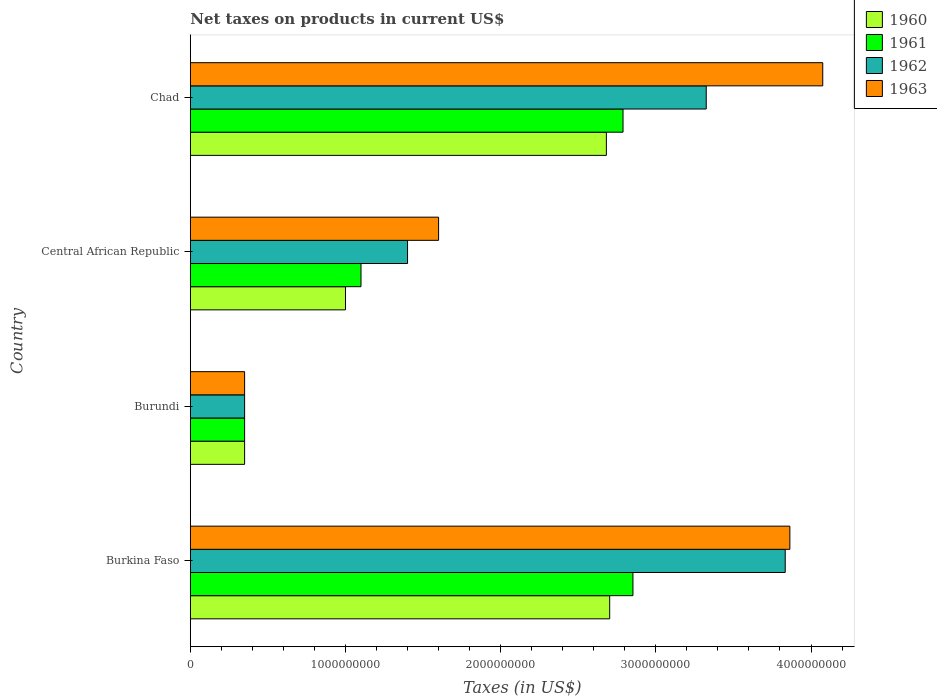Are the number of bars per tick equal to the number of legend labels?
Your answer should be very brief. Yes. How many bars are there on the 1st tick from the bottom?
Make the answer very short. 4. What is the label of the 1st group of bars from the top?
Your response must be concise. Chad. What is the net taxes on products in 1961 in Central African Republic?
Give a very brief answer. 1.10e+09. Across all countries, what is the maximum net taxes on products in 1962?
Offer a terse response. 3.83e+09. Across all countries, what is the minimum net taxes on products in 1961?
Make the answer very short. 3.50e+08. In which country was the net taxes on products in 1960 maximum?
Your response must be concise. Burkina Faso. In which country was the net taxes on products in 1963 minimum?
Give a very brief answer. Burundi. What is the total net taxes on products in 1963 in the graph?
Offer a very short reply. 9.89e+09. What is the difference between the net taxes on products in 1962 in Burundi and that in Chad?
Your response must be concise. -2.97e+09. What is the difference between the net taxes on products in 1962 in Chad and the net taxes on products in 1960 in Central African Republic?
Give a very brief answer. 2.32e+09. What is the average net taxes on products in 1961 per country?
Your answer should be compact. 1.77e+09. What is the difference between the net taxes on products in 1961 and net taxes on products in 1960 in Central African Republic?
Ensure brevity in your answer.  1.00e+08. What is the ratio of the net taxes on products in 1961 in Burkina Faso to that in Central African Republic?
Ensure brevity in your answer.  2.59. Is the difference between the net taxes on products in 1961 in Burundi and Chad greater than the difference between the net taxes on products in 1960 in Burundi and Chad?
Provide a short and direct response. No. What is the difference between the highest and the second highest net taxes on products in 1960?
Keep it short and to the point. 2.13e+07. What is the difference between the highest and the lowest net taxes on products in 1962?
Your answer should be very brief. 3.48e+09. In how many countries, is the net taxes on products in 1962 greater than the average net taxes on products in 1962 taken over all countries?
Give a very brief answer. 2. What does the 3rd bar from the top in Chad represents?
Make the answer very short. 1961. How many bars are there?
Offer a very short reply. 16. Are all the bars in the graph horizontal?
Provide a short and direct response. Yes. Does the graph contain any zero values?
Give a very brief answer. No. Does the graph contain grids?
Provide a succinct answer. No. Where does the legend appear in the graph?
Your answer should be very brief. Top right. How many legend labels are there?
Give a very brief answer. 4. What is the title of the graph?
Provide a short and direct response. Net taxes on products in current US$. Does "1964" appear as one of the legend labels in the graph?
Make the answer very short. No. What is the label or title of the X-axis?
Your answer should be compact. Taxes (in US$). What is the Taxes (in US$) in 1960 in Burkina Faso?
Provide a succinct answer. 2.70e+09. What is the Taxes (in US$) of 1961 in Burkina Faso?
Provide a succinct answer. 2.85e+09. What is the Taxes (in US$) in 1962 in Burkina Faso?
Your answer should be very brief. 3.83e+09. What is the Taxes (in US$) of 1963 in Burkina Faso?
Your answer should be very brief. 3.86e+09. What is the Taxes (in US$) in 1960 in Burundi?
Provide a succinct answer. 3.50e+08. What is the Taxes (in US$) of 1961 in Burundi?
Provide a succinct answer. 3.50e+08. What is the Taxes (in US$) of 1962 in Burundi?
Offer a terse response. 3.50e+08. What is the Taxes (in US$) in 1963 in Burundi?
Your answer should be very brief. 3.50e+08. What is the Taxes (in US$) of 1960 in Central African Republic?
Your answer should be compact. 1.00e+09. What is the Taxes (in US$) in 1961 in Central African Republic?
Ensure brevity in your answer.  1.10e+09. What is the Taxes (in US$) of 1962 in Central African Republic?
Make the answer very short. 1.40e+09. What is the Taxes (in US$) of 1963 in Central African Republic?
Provide a succinct answer. 1.60e+09. What is the Taxes (in US$) of 1960 in Chad?
Give a very brief answer. 2.68e+09. What is the Taxes (in US$) in 1961 in Chad?
Keep it short and to the point. 2.79e+09. What is the Taxes (in US$) in 1962 in Chad?
Ensure brevity in your answer.  3.32e+09. What is the Taxes (in US$) in 1963 in Chad?
Provide a short and direct response. 4.08e+09. Across all countries, what is the maximum Taxes (in US$) of 1960?
Your response must be concise. 2.70e+09. Across all countries, what is the maximum Taxes (in US$) of 1961?
Offer a terse response. 2.85e+09. Across all countries, what is the maximum Taxes (in US$) of 1962?
Your answer should be compact. 3.83e+09. Across all countries, what is the maximum Taxes (in US$) in 1963?
Your response must be concise. 4.08e+09. Across all countries, what is the minimum Taxes (in US$) in 1960?
Give a very brief answer. 3.50e+08. Across all countries, what is the minimum Taxes (in US$) in 1961?
Ensure brevity in your answer.  3.50e+08. Across all countries, what is the minimum Taxes (in US$) in 1962?
Ensure brevity in your answer.  3.50e+08. Across all countries, what is the minimum Taxes (in US$) in 1963?
Offer a very short reply. 3.50e+08. What is the total Taxes (in US$) in 1960 in the graph?
Your answer should be compact. 6.73e+09. What is the total Taxes (in US$) of 1961 in the graph?
Ensure brevity in your answer.  7.09e+09. What is the total Taxes (in US$) in 1962 in the graph?
Give a very brief answer. 8.91e+09. What is the total Taxes (in US$) in 1963 in the graph?
Offer a very short reply. 9.89e+09. What is the difference between the Taxes (in US$) of 1960 in Burkina Faso and that in Burundi?
Keep it short and to the point. 2.35e+09. What is the difference between the Taxes (in US$) of 1961 in Burkina Faso and that in Burundi?
Provide a succinct answer. 2.50e+09. What is the difference between the Taxes (in US$) in 1962 in Burkina Faso and that in Burundi?
Offer a very short reply. 3.48e+09. What is the difference between the Taxes (in US$) of 1963 in Burkina Faso and that in Burundi?
Provide a short and direct response. 3.51e+09. What is the difference between the Taxes (in US$) in 1960 in Burkina Faso and that in Central African Republic?
Offer a terse response. 1.70e+09. What is the difference between the Taxes (in US$) in 1961 in Burkina Faso and that in Central African Republic?
Your answer should be very brief. 1.75e+09. What is the difference between the Taxes (in US$) of 1962 in Burkina Faso and that in Central African Republic?
Give a very brief answer. 2.43e+09. What is the difference between the Taxes (in US$) in 1963 in Burkina Faso and that in Central African Republic?
Keep it short and to the point. 2.26e+09. What is the difference between the Taxes (in US$) in 1960 in Burkina Faso and that in Chad?
Your answer should be very brief. 2.13e+07. What is the difference between the Taxes (in US$) in 1961 in Burkina Faso and that in Chad?
Ensure brevity in your answer.  6.39e+07. What is the difference between the Taxes (in US$) of 1962 in Burkina Faso and that in Chad?
Offer a terse response. 5.09e+08. What is the difference between the Taxes (in US$) of 1963 in Burkina Faso and that in Chad?
Provide a short and direct response. -2.12e+08. What is the difference between the Taxes (in US$) in 1960 in Burundi and that in Central African Republic?
Your answer should be compact. -6.50e+08. What is the difference between the Taxes (in US$) of 1961 in Burundi and that in Central African Republic?
Keep it short and to the point. -7.50e+08. What is the difference between the Taxes (in US$) of 1962 in Burundi and that in Central African Republic?
Offer a very short reply. -1.05e+09. What is the difference between the Taxes (in US$) of 1963 in Burundi and that in Central African Republic?
Your answer should be very brief. -1.25e+09. What is the difference between the Taxes (in US$) of 1960 in Burundi and that in Chad?
Offer a very short reply. -2.33e+09. What is the difference between the Taxes (in US$) in 1961 in Burundi and that in Chad?
Provide a short and direct response. -2.44e+09. What is the difference between the Taxes (in US$) of 1962 in Burundi and that in Chad?
Offer a very short reply. -2.97e+09. What is the difference between the Taxes (in US$) of 1963 in Burundi and that in Chad?
Make the answer very short. -3.73e+09. What is the difference between the Taxes (in US$) in 1960 in Central African Republic and that in Chad?
Ensure brevity in your answer.  -1.68e+09. What is the difference between the Taxes (in US$) in 1961 in Central African Republic and that in Chad?
Your response must be concise. -1.69e+09. What is the difference between the Taxes (in US$) in 1962 in Central African Republic and that in Chad?
Make the answer very short. -1.92e+09. What is the difference between the Taxes (in US$) of 1963 in Central African Republic and that in Chad?
Your response must be concise. -2.48e+09. What is the difference between the Taxes (in US$) in 1960 in Burkina Faso and the Taxes (in US$) in 1961 in Burundi?
Make the answer very short. 2.35e+09. What is the difference between the Taxes (in US$) of 1960 in Burkina Faso and the Taxes (in US$) of 1962 in Burundi?
Give a very brief answer. 2.35e+09. What is the difference between the Taxes (in US$) in 1960 in Burkina Faso and the Taxes (in US$) in 1963 in Burundi?
Offer a very short reply. 2.35e+09. What is the difference between the Taxes (in US$) of 1961 in Burkina Faso and the Taxes (in US$) of 1962 in Burundi?
Keep it short and to the point. 2.50e+09. What is the difference between the Taxes (in US$) in 1961 in Burkina Faso and the Taxes (in US$) in 1963 in Burundi?
Give a very brief answer. 2.50e+09. What is the difference between the Taxes (in US$) in 1962 in Burkina Faso and the Taxes (in US$) in 1963 in Burundi?
Your answer should be very brief. 3.48e+09. What is the difference between the Taxes (in US$) of 1960 in Burkina Faso and the Taxes (in US$) of 1961 in Central African Republic?
Your answer should be very brief. 1.60e+09. What is the difference between the Taxes (in US$) in 1960 in Burkina Faso and the Taxes (in US$) in 1962 in Central African Republic?
Ensure brevity in your answer.  1.30e+09. What is the difference between the Taxes (in US$) in 1960 in Burkina Faso and the Taxes (in US$) in 1963 in Central African Republic?
Your response must be concise. 1.10e+09. What is the difference between the Taxes (in US$) of 1961 in Burkina Faso and the Taxes (in US$) of 1962 in Central African Republic?
Offer a terse response. 1.45e+09. What is the difference between the Taxes (in US$) of 1961 in Burkina Faso and the Taxes (in US$) of 1963 in Central African Republic?
Ensure brevity in your answer.  1.25e+09. What is the difference between the Taxes (in US$) in 1962 in Burkina Faso and the Taxes (in US$) in 1963 in Central African Republic?
Provide a short and direct response. 2.23e+09. What is the difference between the Taxes (in US$) of 1960 in Burkina Faso and the Taxes (in US$) of 1961 in Chad?
Your answer should be compact. -8.59e+07. What is the difference between the Taxes (in US$) of 1960 in Burkina Faso and the Taxes (in US$) of 1962 in Chad?
Offer a very short reply. -6.22e+08. What is the difference between the Taxes (in US$) of 1960 in Burkina Faso and the Taxes (in US$) of 1963 in Chad?
Give a very brief answer. -1.37e+09. What is the difference between the Taxes (in US$) in 1961 in Burkina Faso and the Taxes (in US$) in 1962 in Chad?
Keep it short and to the point. -4.72e+08. What is the difference between the Taxes (in US$) of 1961 in Burkina Faso and the Taxes (in US$) of 1963 in Chad?
Provide a short and direct response. -1.22e+09. What is the difference between the Taxes (in US$) of 1962 in Burkina Faso and the Taxes (in US$) of 1963 in Chad?
Your response must be concise. -2.42e+08. What is the difference between the Taxes (in US$) in 1960 in Burundi and the Taxes (in US$) in 1961 in Central African Republic?
Ensure brevity in your answer.  -7.50e+08. What is the difference between the Taxes (in US$) of 1960 in Burundi and the Taxes (in US$) of 1962 in Central African Republic?
Give a very brief answer. -1.05e+09. What is the difference between the Taxes (in US$) in 1960 in Burundi and the Taxes (in US$) in 1963 in Central African Republic?
Your response must be concise. -1.25e+09. What is the difference between the Taxes (in US$) of 1961 in Burundi and the Taxes (in US$) of 1962 in Central African Republic?
Keep it short and to the point. -1.05e+09. What is the difference between the Taxes (in US$) in 1961 in Burundi and the Taxes (in US$) in 1963 in Central African Republic?
Provide a succinct answer. -1.25e+09. What is the difference between the Taxes (in US$) in 1962 in Burundi and the Taxes (in US$) in 1963 in Central African Republic?
Offer a terse response. -1.25e+09. What is the difference between the Taxes (in US$) of 1960 in Burundi and the Taxes (in US$) of 1961 in Chad?
Provide a short and direct response. -2.44e+09. What is the difference between the Taxes (in US$) in 1960 in Burundi and the Taxes (in US$) in 1962 in Chad?
Keep it short and to the point. -2.97e+09. What is the difference between the Taxes (in US$) in 1960 in Burundi and the Taxes (in US$) in 1963 in Chad?
Keep it short and to the point. -3.73e+09. What is the difference between the Taxes (in US$) of 1961 in Burundi and the Taxes (in US$) of 1962 in Chad?
Your answer should be compact. -2.97e+09. What is the difference between the Taxes (in US$) in 1961 in Burundi and the Taxes (in US$) in 1963 in Chad?
Make the answer very short. -3.73e+09. What is the difference between the Taxes (in US$) in 1962 in Burundi and the Taxes (in US$) in 1963 in Chad?
Your response must be concise. -3.73e+09. What is the difference between the Taxes (in US$) of 1960 in Central African Republic and the Taxes (in US$) of 1961 in Chad?
Provide a short and direct response. -1.79e+09. What is the difference between the Taxes (in US$) of 1960 in Central African Republic and the Taxes (in US$) of 1962 in Chad?
Your answer should be very brief. -2.32e+09. What is the difference between the Taxes (in US$) in 1960 in Central African Republic and the Taxes (in US$) in 1963 in Chad?
Make the answer very short. -3.08e+09. What is the difference between the Taxes (in US$) of 1961 in Central African Republic and the Taxes (in US$) of 1962 in Chad?
Provide a succinct answer. -2.22e+09. What is the difference between the Taxes (in US$) of 1961 in Central African Republic and the Taxes (in US$) of 1963 in Chad?
Keep it short and to the point. -2.98e+09. What is the difference between the Taxes (in US$) of 1962 in Central African Republic and the Taxes (in US$) of 1963 in Chad?
Provide a succinct answer. -2.68e+09. What is the average Taxes (in US$) in 1960 per country?
Keep it short and to the point. 1.68e+09. What is the average Taxes (in US$) of 1961 per country?
Your response must be concise. 1.77e+09. What is the average Taxes (in US$) in 1962 per country?
Keep it short and to the point. 2.23e+09. What is the average Taxes (in US$) in 1963 per country?
Provide a succinct answer. 2.47e+09. What is the difference between the Taxes (in US$) of 1960 and Taxes (in US$) of 1961 in Burkina Faso?
Your answer should be very brief. -1.50e+08. What is the difference between the Taxes (in US$) of 1960 and Taxes (in US$) of 1962 in Burkina Faso?
Offer a terse response. -1.13e+09. What is the difference between the Taxes (in US$) in 1960 and Taxes (in US$) in 1963 in Burkina Faso?
Offer a terse response. -1.16e+09. What is the difference between the Taxes (in US$) in 1961 and Taxes (in US$) in 1962 in Burkina Faso?
Provide a succinct answer. -9.81e+08. What is the difference between the Taxes (in US$) in 1961 and Taxes (in US$) in 1963 in Burkina Faso?
Provide a short and direct response. -1.01e+09. What is the difference between the Taxes (in US$) in 1962 and Taxes (in US$) in 1963 in Burkina Faso?
Provide a succinct answer. -3.00e+07. What is the difference between the Taxes (in US$) in 1960 and Taxes (in US$) in 1963 in Burundi?
Your response must be concise. 0. What is the difference between the Taxes (in US$) in 1962 and Taxes (in US$) in 1963 in Burundi?
Provide a short and direct response. 0. What is the difference between the Taxes (in US$) of 1960 and Taxes (in US$) of 1961 in Central African Republic?
Provide a short and direct response. -1.00e+08. What is the difference between the Taxes (in US$) in 1960 and Taxes (in US$) in 1962 in Central African Republic?
Offer a very short reply. -4.00e+08. What is the difference between the Taxes (in US$) of 1960 and Taxes (in US$) of 1963 in Central African Republic?
Your answer should be compact. -6.00e+08. What is the difference between the Taxes (in US$) of 1961 and Taxes (in US$) of 1962 in Central African Republic?
Make the answer very short. -3.00e+08. What is the difference between the Taxes (in US$) in 1961 and Taxes (in US$) in 1963 in Central African Republic?
Offer a very short reply. -5.00e+08. What is the difference between the Taxes (in US$) in 1962 and Taxes (in US$) in 1963 in Central African Republic?
Provide a short and direct response. -2.00e+08. What is the difference between the Taxes (in US$) of 1960 and Taxes (in US$) of 1961 in Chad?
Your answer should be compact. -1.07e+08. What is the difference between the Taxes (in US$) of 1960 and Taxes (in US$) of 1962 in Chad?
Your response must be concise. -6.44e+08. What is the difference between the Taxes (in US$) in 1960 and Taxes (in US$) in 1963 in Chad?
Your answer should be compact. -1.39e+09. What is the difference between the Taxes (in US$) of 1961 and Taxes (in US$) of 1962 in Chad?
Offer a terse response. -5.36e+08. What is the difference between the Taxes (in US$) in 1961 and Taxes (in US$) in 1963 in Chad?
Your response must be concise. -1.29e+09. What is the difference between the Taxes (in US$) of 1962 and Taxes (in US$) of 1963 in Chad?
Offer a very short reply. -7.51e+08. What is the ratio of the Taxes (in US$) in 1960 in Burkina Faso to that in Burundi?
Offer a very short reply. 7.72. What is the ratio of the Taxes (in US$) in 1961 in Burkina Faso to that in Burundi?
Your answer should be compact. 8.15. What is the ratio of the Taxes (in US$) in 1962 in Burkina Faso to that in Burundi?
Your answer should be compact. 10.95. What is the ratio of the Taxes (in US$) of 1963 in Burkina Faso to that in Burundi?
Your answer should be very brief. 11.04. What is the ratio of the Taxes (in US$) in 1960 in Burkina Faso to that in Central African Republic?
Make the answer very short. 2.7. What is the ratio of the Taxes (in US$) in 1961 in Burkina Faso to that in Central African Republic?
Provide a succinct answer. 2.59. What is the ratio of the Taxes (in US$) in 1962 in Burkina Faso to that in Central African Republic?
Your answer should be compact. 2.74. What is the ratio of the Taxes (in US$) of 1963 in Burkina Faso to that in Central African Republic?
Offer a terse response. 2.41. What is the ratio of the Taxes (in US$) of 1961 in Burkina Faso to that in Chad?
Offer a terse response. 1.02. What is the ratio of the Taxes (in US$) of 1962 in Burkina Faso to that in Chad?
Provide a short and direct response. 1.15. What is the ratio of the Taxes (in US$) in 1963 in Burkina Faso to that in Chad?
Your response must be concise. 0.95. What is the ratio of the Taxes (in US$) in 1961 in Burundi to that in Central African Republic?
Offer a terse response. 0.32. What is the ratio of the Taxes (in US$) in 1962 in Burundi to that in Central African Republic?
Offer a very short reply. 0.25. What is the ratio of the Taxes (in US$) of 1963 in Burundi to that in Central African Republic?
Your answer should be very brief. 0.22. What is the ratio of the Taxes (in US$) in 1960 in Burundi to that in Chad?
Give a very brief answer. 0.13. What is the ratio of the Taxes (in US$) of 1961 in Burundi to that in Chad?
Offer a terse response. 0.13. What is the ratio of the Taxes (in US$) of 1962 in Burundi to that in Chad?
Make the answer very short. 0.11. What is the ratio of the Taxes (in US$) of 1963 in Burundi to that in Chad?
Your response must be concise. 0.09. What is the ratio of the Taxes (in US$) in 1960 in Central African Republic to that in Chad?
Your answer should be compact. 0.37. What is the ratio of the Taxes (in US$) in 1961 in Central African Republic to that in Chad?
Provide a short and direct response. 0.39. What is the ratio of the Taxes (in US$) of 1962 in Central African Republic to that in Chad?
Ensure brevity in your answer.  0.42. What is the ratio of the Taxes (in US$) of 1963 in Central African Republic to that in Chad?
Offer a terse response. 0.39. What is the difference between the highest and the second highest Taxes (in US$) in 1960?
Provide a short and direct response. 2.13e+07. What is the difference between the highest and the second highest Taxes (in US$) in 1961?
Provide a short and direct response. 6.39e+07. What is the difference between the highest and the second highest Taxes (in US$) of 1962?
Provide a short and direct response. 5.09e+08. What is the difference between the highest and the second highest Taxes (in US$) in 1963?
Your answer should be very brief. 2.12e+08. What is the difference between the highest and the lowest Taxes (in US$) in 1960?
Give a very brief answer. 2.35e+09. What is the difference between the highest and the lowest Taxes (in US$) in 1961?
Ensure brevity in your answer.  2.50e+09. What is the difference between the highest and the lowest Taxes (in US$) of 1962?
Give a very brief answer. 3.48e+09. What is the difference between the highest and the lowest Taxes (in US$) of 1963?
Ensure brevity in your answer.  3.73e+09. 